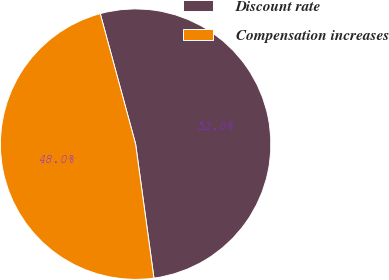Convert chart to OTSL. <chart><loc_0><loc_0><loc_500><loc_500><pie_chart><fcel>Discount rate<fcel>Compensation increases<nl><fcel>52.05%<fcel>47.95%<nl></chart> 